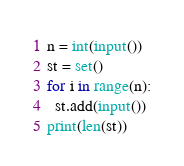<code> <loc_0><loc_0><loc_500><loc_500><_Python_>n = int(input())
st = set()
for i in range(n):
  st.add(input())
print(len(st))</code> 